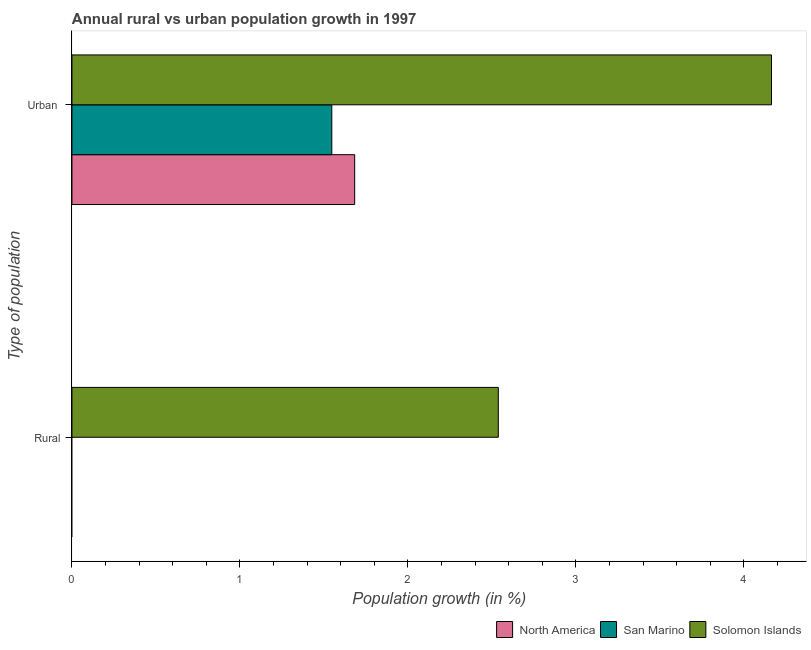Are the number of bars per tick equal to the number of legend labels?
Provide a short and direct response. No. Are the number of bars on each tick of the Y-axis equal?
Give a very brief answer. No. What is the label of the 1st group of bars from the top?
Offer a very short reply. Urban . What is the urban population growth in North America?
Keep it short and to the point. 1.68. Across all countries, what is the maximum urban population growth?
Your answer should be compact. 4.16. Across all countries, what is the minimum rural population growth?
Make the answer very short. 0. In which country was the rural population growth maximum?
Give a very brief answer. Solomon Islands. What is the total rural population growth in the graph?
Your response must be concise. 2.54. What is the difference between the urban population growth in Solomon Islands and that in San Marino?
Give a very brief answer. 2.62. What is the difference between the rural population growth in Solomon Islands and the urban population growth in San Marino?
Give a very brief answer. 0.99. What is the average rural population growth per country?
Your response must be concise. 0.85. What is the difference between the urban population growth and rural population growth in Solomon Islands?
Provide a short and direct response. 1.63. In how many countries, is the rural population growth greater than 1.4 %?
Provide a succinct answer. 1. What is the ratio of the urban population growth in Solomon Islands to that in North America?
Ensure brevity in your answer.  2.47. Is the urban population growth in San Marino less than that in Solomon Islands?
Your answer should be compact. Yes. In how many countries, is the urban population growth greater than the average urban population growth taken over all countries?
Ensure brevity in your answer.  1. How many bars are there?
Provide a succinct answer. 4. Are all the bars in the graph horizontal?
Offer a terse response. Yes. What is the difference between two consecutive major ticks on the X-axis?
Keep it short and to the point. 1. How are the legend labels stacked?
Make the answer very short. Horizontal. What is the title of the graph?
Offer a terse response. Annual rural vs urban population growth in 1997. Does "Mauritius" appear as one of the legend labels in the graph?
Make the answer very short. No. What is the label or title of the X-axis?
Your answer should be compact. Population growth (in %). What is the label or title of the Y-axis?
Ensure brevity in your answer.  Type of population. What is the Population growth (in %) in Solomon Islands in Rural?
Your response must be concise. 2.54. What is the Population growth (in %) of North America in Urban ?
Your answer should be very brief. 1.68. What is the Population growth (in %) in San Marino in Urban ?
Give a very brief answer. 1.55. What is the Population growth (in %) of Solomon Islands in Urban ?
Offer a terse response. 4.16. Across all Type of population, what is the maximum Population growth (in %) of North America?
Keep it short and to the point. 1.68. Across all Type of population, what is the maximum Population growth (in %) in San Marino?
Offer a terse response. 1.55. Across all Type of population, what is the maximum Population growth (in %) in Solomon Islands?
Make the answer very short. 4.16. Across all Type of population, what is the minimum Population growth (in %) in North America?
Provide a short and direct response. 0. Across all Type of population, what is the minimum Population growth (in %) in San Marino?
Make the answer very short. 0. Across all Type of population, what is the minimum Population growth (in %) in Solomon Islands?
Keep it short and to the point. 2.54. What is the total Population growth (in %) in North America in the graph?
Ensure brevity in your answer.  1.68. What is the total Population growth (in %) of San Marino in the graph?
Your response must be concise. 1.55. What is the total Population growth (in %) of Solomon Islands in the graph?
Provide a short and direct response. 6.7. What is the difference between the Population growth (in %) of Solomon Islands in Rural and that in Urban ?
Offer a terse response. -1.63. What is the average Population growth (in %) in North America per Type of population?
Provide a short and direct response. 0.84. What is the average Population growth (in %) in San Marino per Type of population?
Give a very brief answer. 0.77. What is the average Population growth (in %) in Solomon Islands per Type of population?
Give a very brief answer. 3.35. What is the difference between the Population growth (in %) of North America and Population growth (in %) of San Marino in Urban ?
Ensure brevity in your answer.  0.14. What is the difference between the Population growth (in %) of North America and Population growth (in %) of Solomon Islands in Urban ?
Your answer should be very brief. -2.48. What is the difference between the Population growth (in %) in San Marino and Population growth (in %) in Solomon Islands in Urban ?
Keep it short and to the point. -2.62. What is the ratio of the Population growth (in %) of Solomon Islands in Rural to that in Urban ?
Offer a terse response. 0.61. What is the difference between the highest and the second highest Population growth (in %) in Solomon Islands?
Your response must be concise. 1.63. What is the difference between the highest and the lowest Population growth (in %) of North America?
Provide a short and direct response. 1.68. What is the difference between the highest and the lowest Population growth (in %) in San Marino?
Offer a terse response. 1.55. What is the difference between the highest and the lowest Population growth (in %) in Solomon Islands?
Your response must be concise. 1.63. 